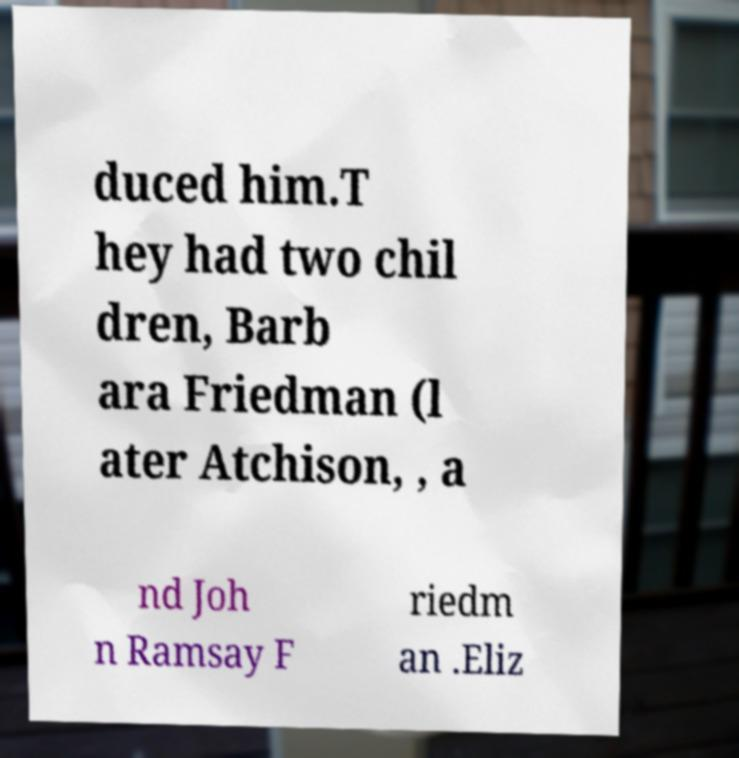Please identify and transcribe the text found in this image. duced him.T hey had two chil dren, Barb ara Friedman (l ater Atchison, , a nd Joh n Ramsay F riedm an .Eliz 